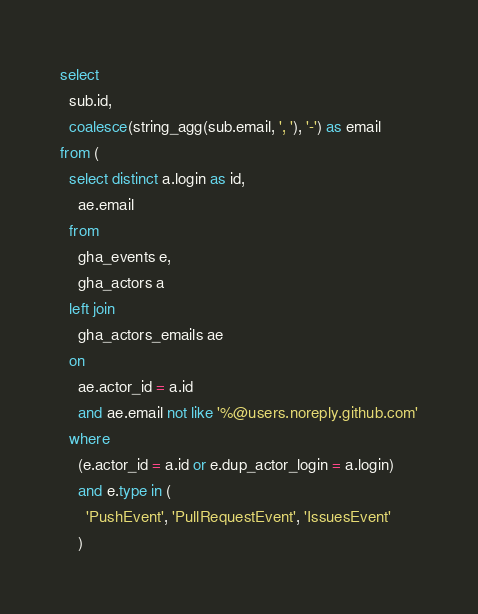<code> <loc_0><loc_0><loc_500><loc_500><_SQL_>select
  sub.id,
  coalesce(string_agg(sub.email, ', '), '-') as email
from (
  select distinct a.login as id,
    ae.email
  from
    gha_events e,
    gha_actors a
  left join
    gha_actors_emails ae
  on
    ae.actor_id = a.id
    and ae.email not like '%@users.noreply.github.com'
  where
    (e.actor_id = a.id or e.dup_actor_login = a.login)
    and e.type in (
      'PushEvent', 'PullRequestEvent', 'IssuesEvent'
    )</code> 